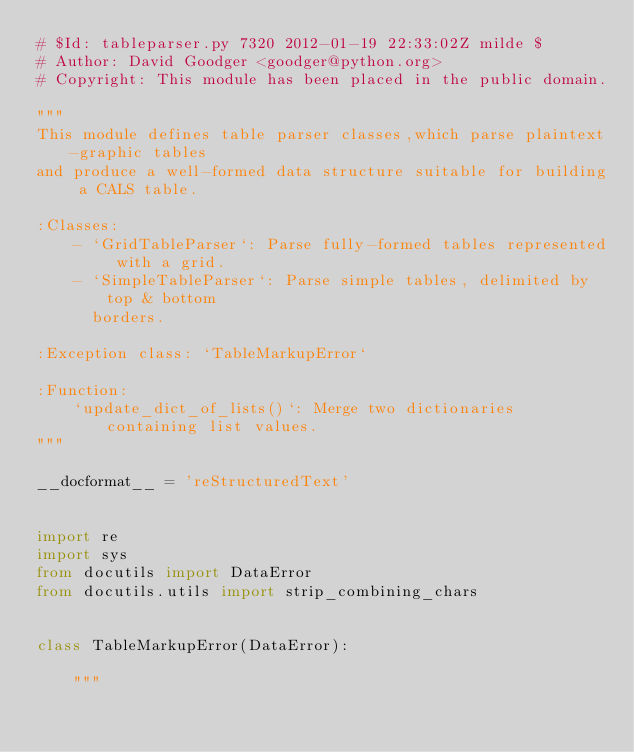<code> <loc_0><loc_0><loc_500><loc_500><_Python_># $Id: tableparser.py 7320 2012-01-19 22:33:02Z milde $
# Author: David Goodger <goodger@python.org>
# Copyright: This module has been placed in the public domain.

"""
This module defines table parser classes,which parse plaintext-graphic tables
and produce a well-formed data structure suitable for building a CALS table.

:Classes:
    - `GridTableParser`: Parse fully-formed tables represented with a grid.
    - `SimpleTableParser`: Parse simple tables, delimited by top & bottom
      borders.

:Exception class: `TableMarkupError`

:Function:
    `update_dict_of_lists()`: Merge two dictionaries containing list values.
"""

__docformat__ = 'reStructuredText'


import re
import sys
from docutils import DataError
from docutils.utils import strip_combining_chars


class TableMarkupError(DataError):

    """</code> 